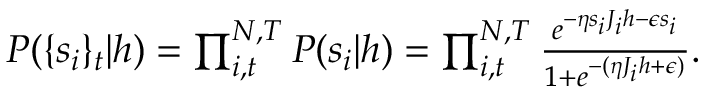Convert formula to latex. <formula><loc_0><loc_0><loc_500><loc_500>\begin{array} { r } { P ( \{ s _ { i } \} _ { t } | h ) = \prod _ { i , t } ^ { N , T } P ( s _ { i } | h ) = \prod _ { i , t } ^ { N , T } \frac { e ^ { - \eta s _ { i } J _ { i } h - \epsilon s _ { i } } } { 1 + e ^ { - ( \eta J _ { i } h + \epsilon ) } } . } \end{array}</formula> 